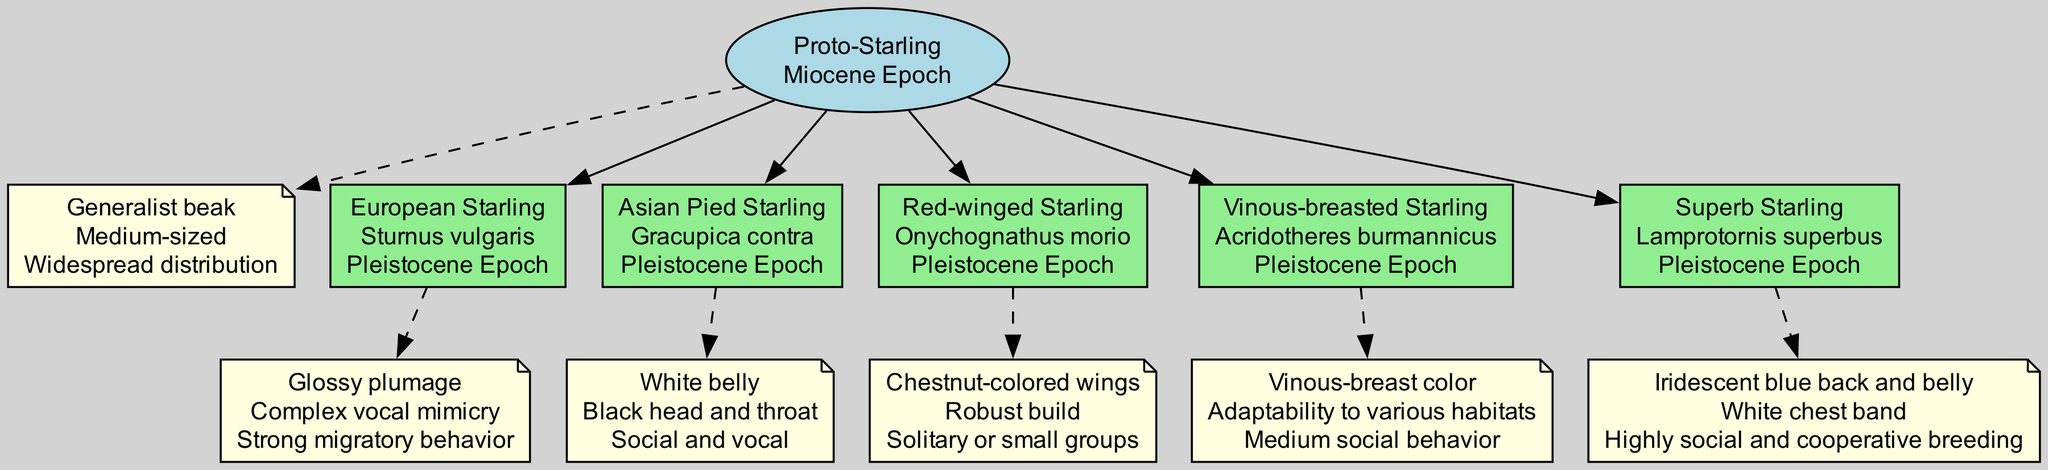What is the common ancestor of the starlings? The diagram clearly identifies the "Proto-Starling" as the common ancestor, making it straightforward to find the answer in its listing.
Answer: Proto-Starling How many branches extend from the common ancestor? By reviewing the diagram, I can count five distinct branches that extend from the "Proto-Starling."
Answer: 5 What traits are associated with the European Starling? The traits for the European Starling are listed directly beneath its name in the diagram, highlighting its unique characteristics.
Answer: Glossy plumage, Complex vocal mimicry, Strong migratory behavior What era does the Asian Pied Starling belong to? The diagram indicates that the Asian Pied Starling branches from the Proto-Starling and shows its corresponding era labeled next to it, which is the Pleistocene Epoch.
Answer: Pleistocene Epoch Which starling species has a robust build? The diagram specifies traits of the Red-winged Starling, which include having a robust build, allowing me to answer the question based on its listed traits.
Answer: Red-winged Starling How many traits are associated with the Superb Starling? By examining the traits associated with the Superb Starling node, I see three characteristics listed straight away, allowing for a quick count.
Answer: 3 Which starling has a white chest band? The diagram states that the Superb Starling has a white chest band among its traits, indicating this characteristic clearly.
Answer: Superb Starling What is the primary feature that distinguishes the Vinous-breasted Starling? The diagram shows that the Vinous-breasted Starling is characterized by its vinous-breast color, which stands out in its traits section.
Answer: Vinous-breast color Name one trait of the Proto-Starling. The diagram showcases traits for the Proto-Starling, one of which is its generalist beak, clearly displayed in its respective section.
Answer: Generalist beak 